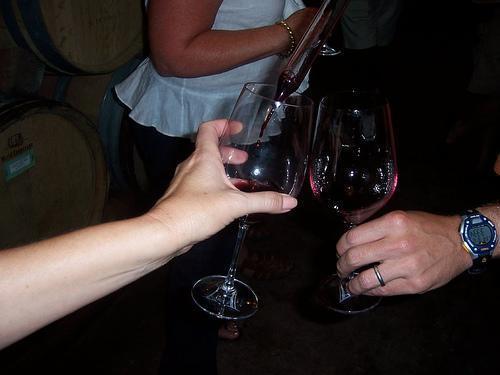How many glasses are there?
Give a very brief answer. 2. How many people are there?
Give a very brief answer. 3. How many people are in the picture?
Give a very brief answer. 3. How many wine glasses are there?
Give a very brief answer. 2. How many elephants are in this photo?
Give a very brief answer. 0. 